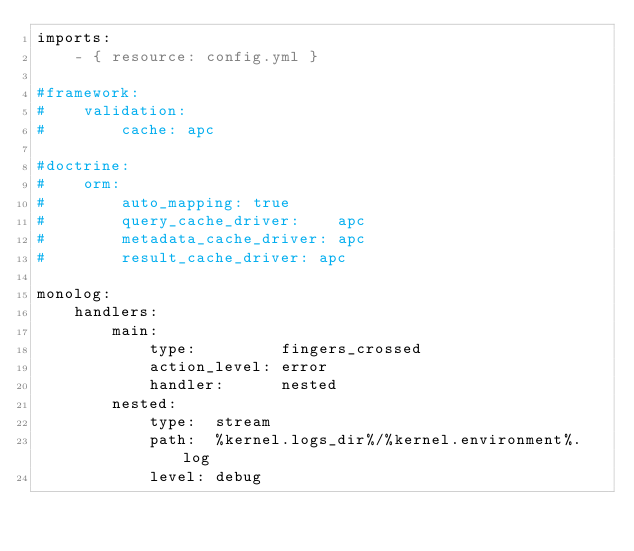Convert code to text. <code><loc_0><loc_0><loc_500><loc_500><_YAML_>imports:
    - { resource: config.yml }

#framework:
#    validation:
#        cache: apc

#doctrine:
#    orm:
#        auto_mapping: true
#        query_cache_driver:    apc
#        metadata_cache_driver: apc
#        result_cache_driver: apc

monolog:
    handlers:
        main:
            type:         fingers_crossed
            action_level: error
            handler:      nested
        nested:
            type:  stream
            path:  %kernel.logs_dir%/%kernel.environment%.log
            level: debug
</code> 